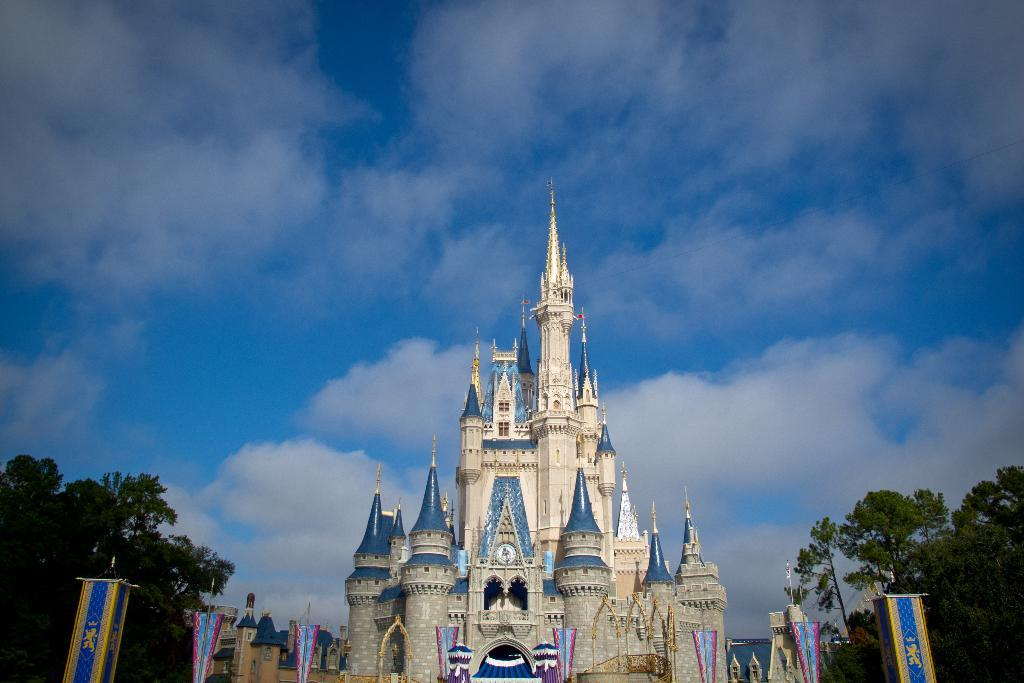What is the main subject of the image? The main subject of the image is a castle construction. What decorative elements can be seen in the image? Banners are present in the image. What type of natural elements are visible in the image? There are trees in the image. How would you describe the weather in the image? The sky is cloudy in the image. What type of pear is being used as a decoration on the castle in the image? There is no pear present in the image; it features a castle construction with banners and trees. Can you tell me how the brain is being used in the construction of the castle in the image? There is no mention of a brain or its use in the construction of the castle in the image. 